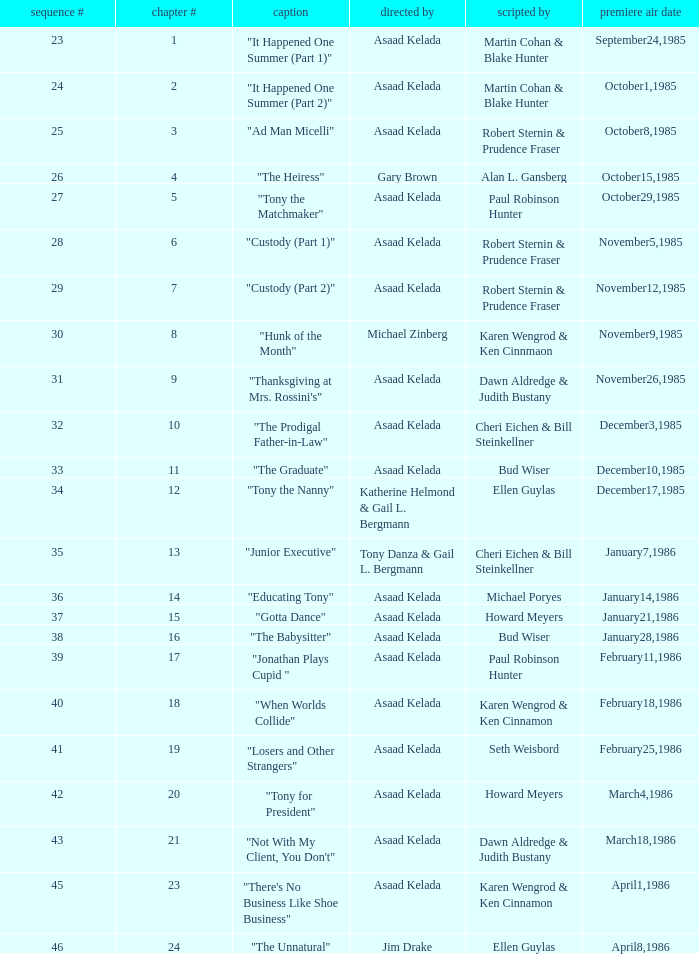What is the date of the episode written by Michael Poryes? January14,1986. 